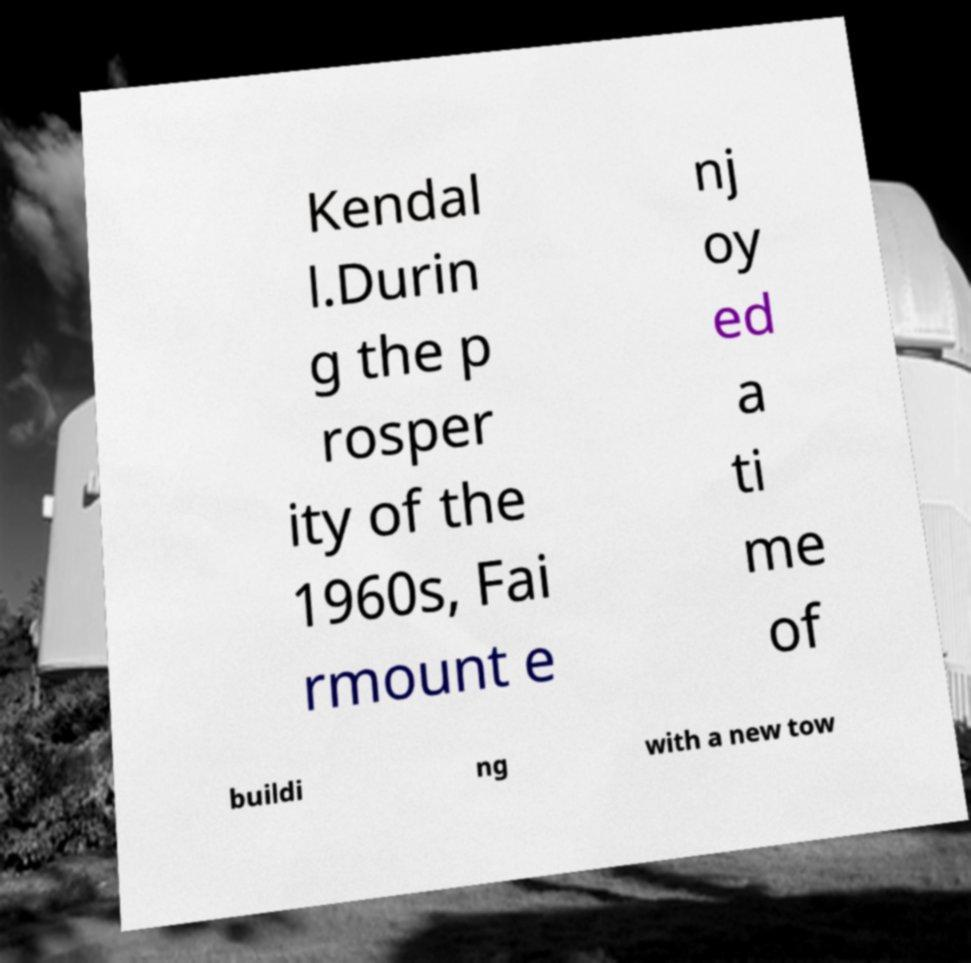Please identify and transcribe the text found in this image. Kendal l.Durin g the p rosper ity of the 1960s, Fai rmount e nj oy ed a ti me of buildi ng with a new tow 